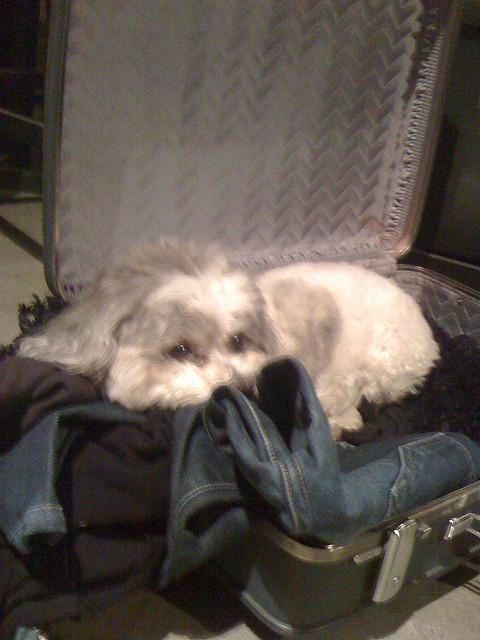Is the dog happy?
Answer briefly. No. What animal is this?
Short answer required. Dog. What are the animals laying in?
Be succinct. Suitcase. What breed is this dog?
Answer briefly. Poodle. What is the white fuzzy object in the suitcase?
Answer briefly. Dog. 